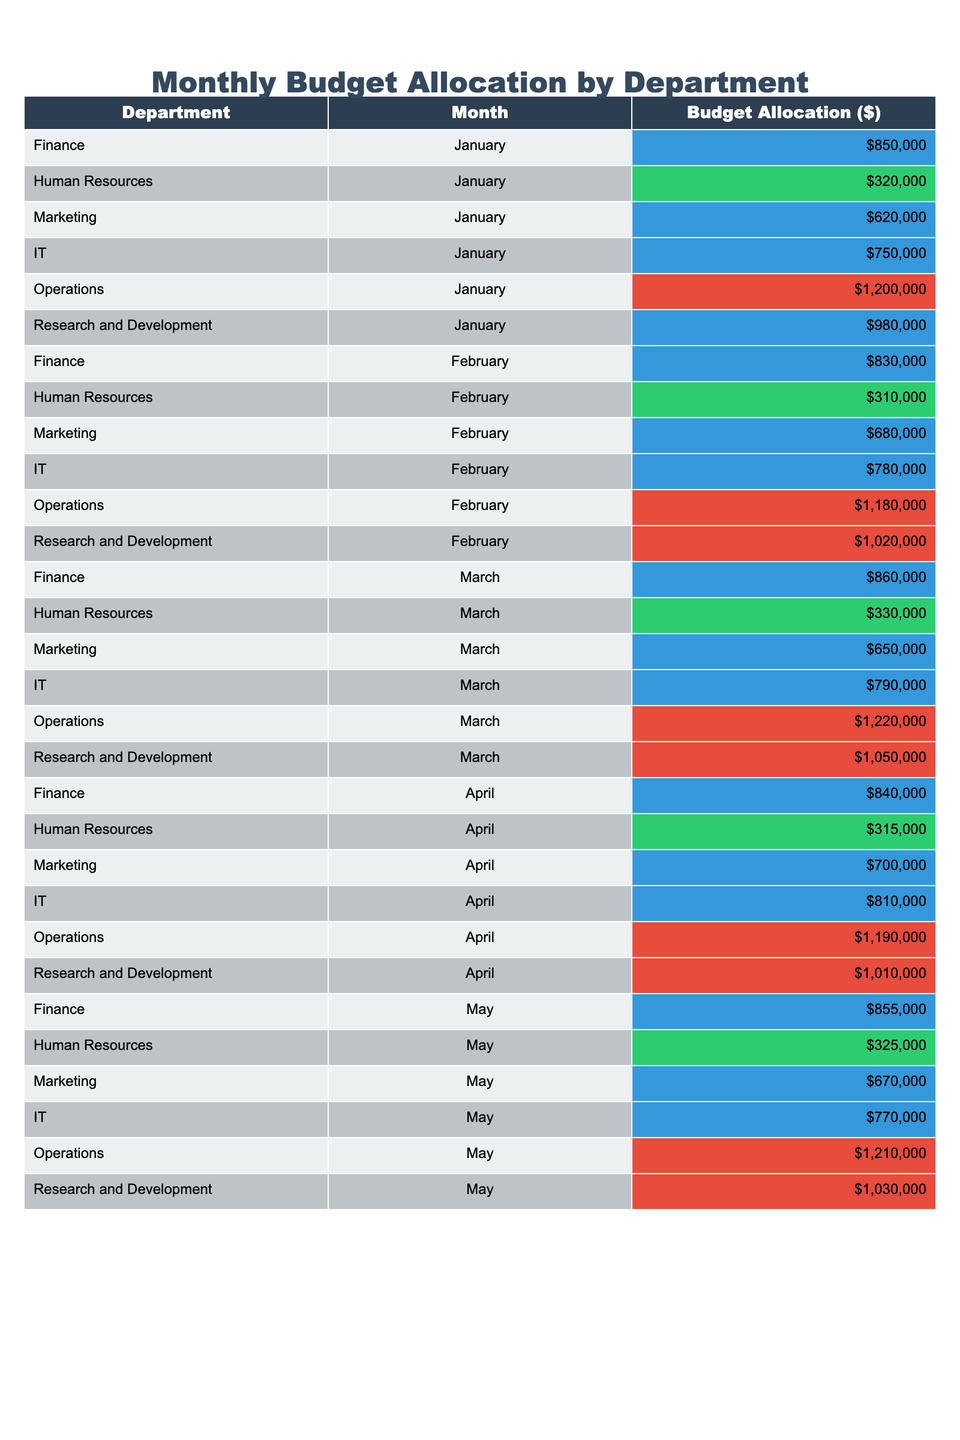What is the total budget allocation for the Operations department in January? The table shows the budget allocation for the Operations department for January which is $1,200,000.
Answer: $1,200,000 What is the budget for the Marketing department in March? According to the table, the budget for the Marketing department in March is $650,000.
Answer: $650,000 Which department has the highest budget allocation in May? The table indicates that the Operations department has the highest budget allocation in May with $1,210,000.
Answer: Operations What is the average budget allocation for the Finance department over the five months? The budget allocations for the Finance department are $850,000, $830,000, $860,000, $840,000, and $855,000. Their sum is $4,235,000, and the average is $4,235,000 divided by 5, which equals $847,000.
Answer: $847,000 Is the budget allocation for IT in April greater than $800,000? In April, the budget allocation for IT is $810,000, which is greater than $800,000.
Answer: Yes What is the difference in budget allocation for the Research and Development department between January and March? The allocation for Research and Development in January is $980,000 and in March it is $1,050,000. The difference is $1,050,000 - $980,000 = $70,000.
Answer: $70,000 Which department had a budget reduction from January to February? By comparing the allocations, the Marketing department decreased from $620,000 in January to $680,000 in February, which indicates an increase, while the Human Resources department dropped from $320,000 to $310,000, confirming a reduction.
Answer: Human Resources What was the total budget allocation for all departments combined in February? Adding all the budget allocations for February: Finance $830,000 + Human Resources $310,000 + Marketing $680,000 + IT $780,000 + Operations $1,180,000 + Research and Development $1,020,000 gives a total of $4,800,000.
Answer: $4,800,000 Did the Marketing department receive a smaller budget allocation in January compared to the IT department? The Marketing department received $620,000 while the IT department got $750,000 in January, meaning Marketing's allocation is smaller.
Answer: Yes What is the maximum budget allocation across all departments and months? After reviewing the table, the maximum budget allocation is found in the Operations department for January, which is $1,200,000.
Answer: $1,200,000 